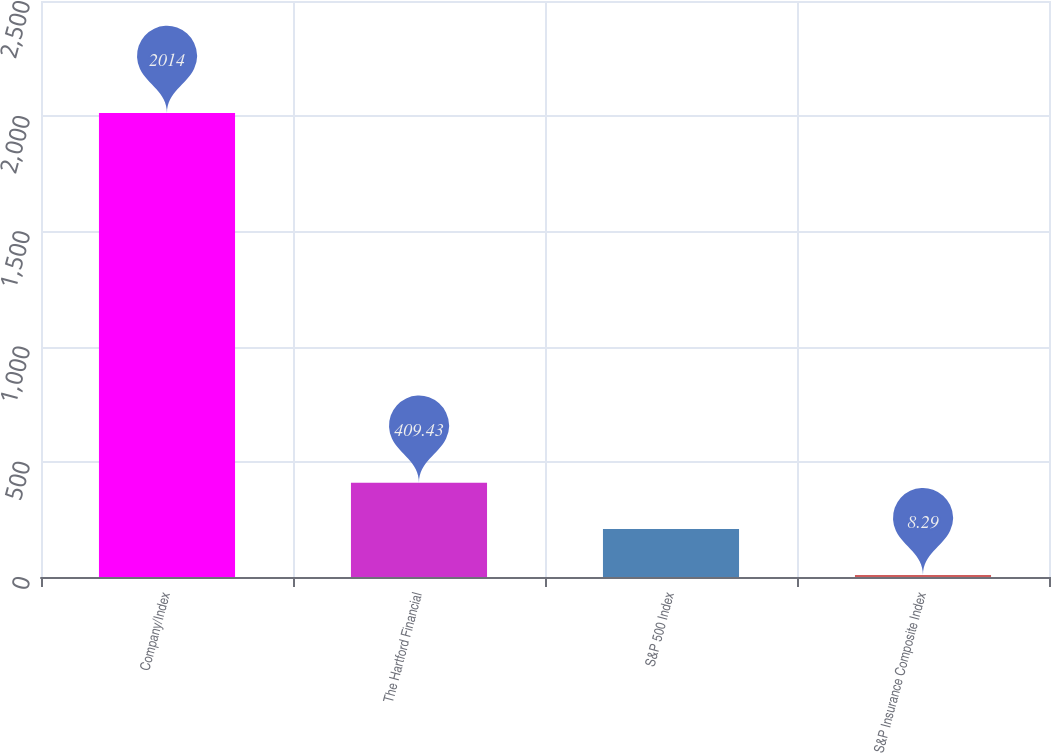<chart> <loc_0><loc_0><loc_500><loc_500><bar_chart><fcel>Company/Index<fcel>The Hartford Financial<fcel>S&P 500 Index<fcel>S&P Insurance Composite Index<nl><fcel>2014<fcel>409.43<fcel>208.86<fcel>8.29<nl></chart> 